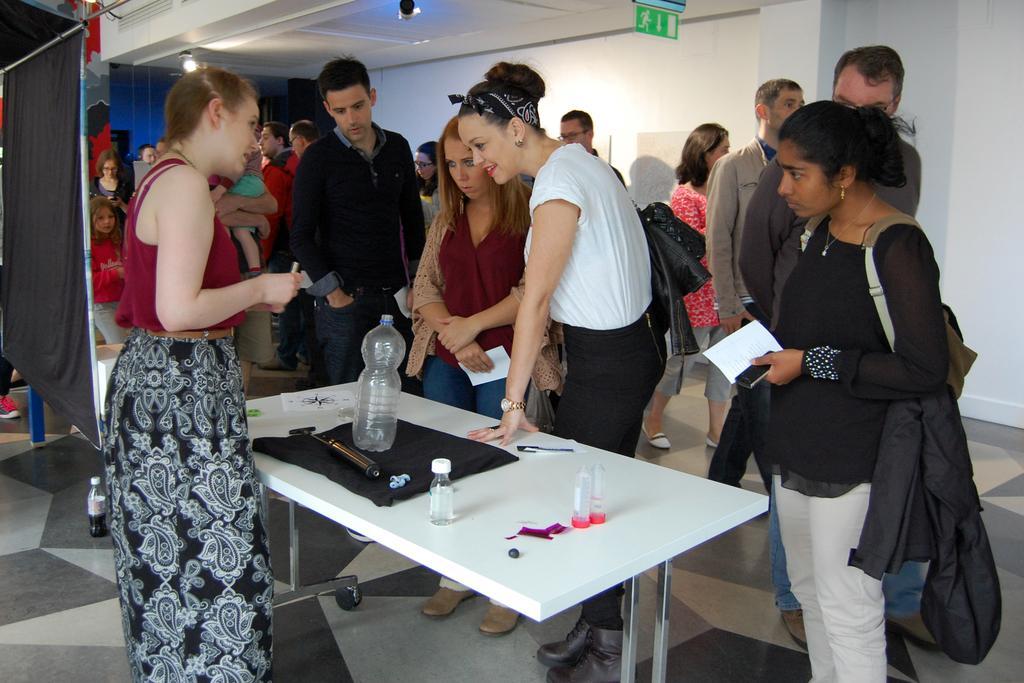Could you give a brief overview of what you see in this image? In this picture we can see persons standing on the floor. Here we can see few persons standing in front of a table and on the table we can see bottles and knife , a cloth. On the background there is a wall. This is sign board. These are lights. 